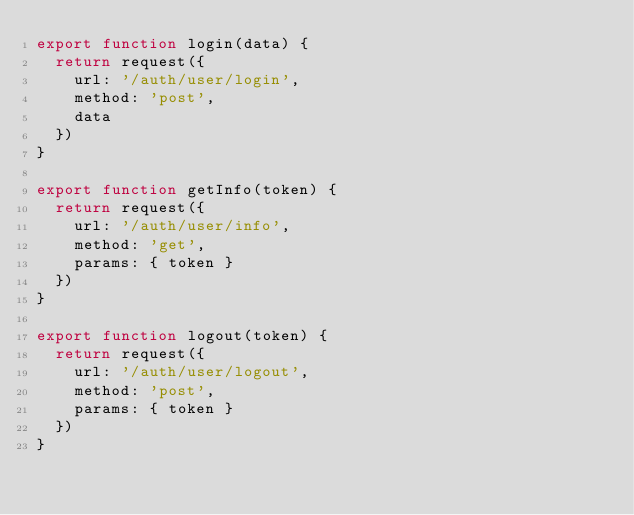<code> <loc_0><loc_0><loc_500><loc_500><_JavaScript_>export function login(data) {
  return request({
    url: '/auth/user/login',
    method: 'post',
    data
  })
}

export function getInfo(token) {
  return request({
    url: '/auth/user/info',
    method: 'get',
    params: { token }
  })
}

export function logout(token) {
  return request({
    url: '/auth/user/logout',
    method: 'post',
    params: { token }
  })
}
</code> 